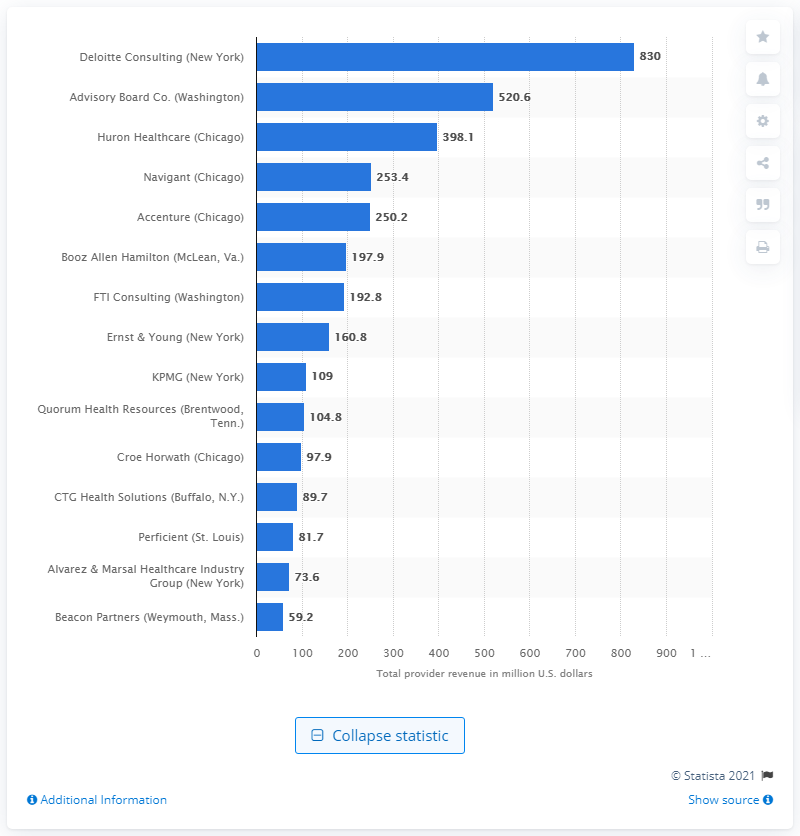Identify some key points in this picture. In 2013, Ernst & Young generated approximately 160.8 million dollars in revenue. 